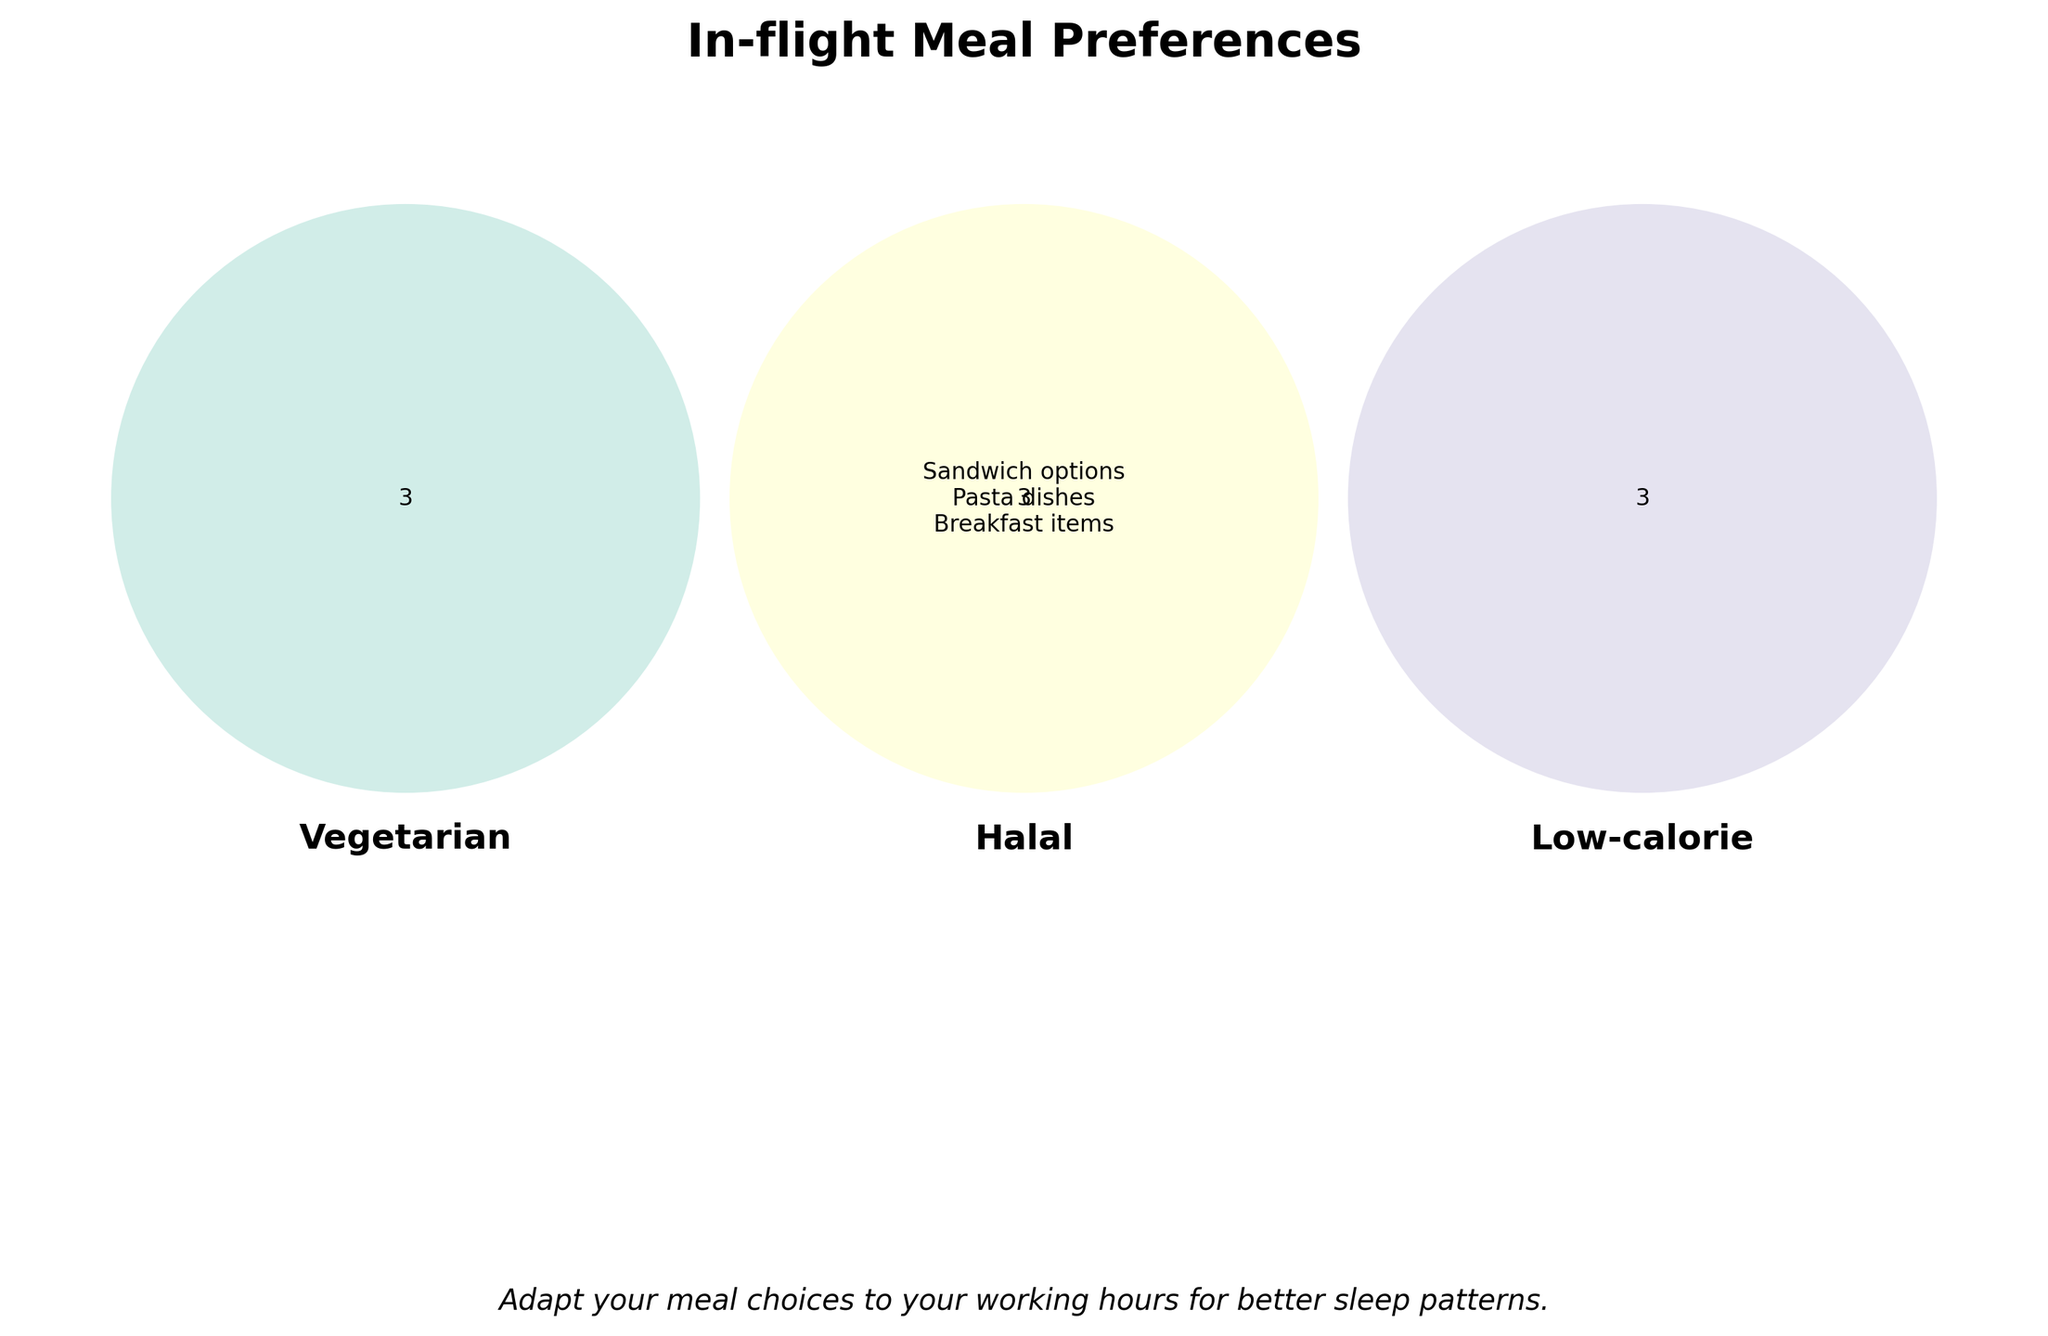What are the overlapping meal preferences between Vegetarian and Halal options in the Venn Diagram? Look at the overlapping section of the Venn Diagram between Vegetarian and Halal categories. Identify the meal preferences in this overlapping region.
Answer: None How many meal preferences are in the center of the Venn Diagram labeled "All"? Check the center of the Venn Diagram where it lists the "All" category. Count the number of meal preferences listed there.
Answer: 3 Which category has a preference for Middle Eastern cuisine? Look for the section labeled "Middle Eastern cuisine" and identify the category it belongs to.
Answer: Halal Are there low-calorie meal preferences that overlap with any other category? Examine the portion of the Venn Diagram assigned for Low-calorie preferences to see if any of them intersect with other categories.
Answer: No Which meal preferences are exclusively Vegetarian and do not overlap with any other category? Look at the section of the Venn Diagram corresponding only to Vegetarian, with no overlaps. List the meal preferences found there.
Answer: Fresh salads, Fruit platters Which category has the most unique meal preferences that do not overlap with others? Identify each category's unique section and count the number of meal preferences. The category with the most preferences is the answer.
Answer: Vegetarian If someone prefers Grilled chicken, which meal category should they choose? Locate Grilled chicken on the Venn Diagram and identify the category associated with this preference.
Answer: Halal Is there a meal preference common to all three categories (Vegetarian, Halal, Low-calorie)? Check the center of the Venn Diagram's intersections to see if any single meal preference is listed across all three categories.
Answer: No Which category includes meal options for lean protein dishes and light desserts? Locate the meal preferences for lean protein dishes and light desserts and identify the associated category.
Answer: Low-calorie 